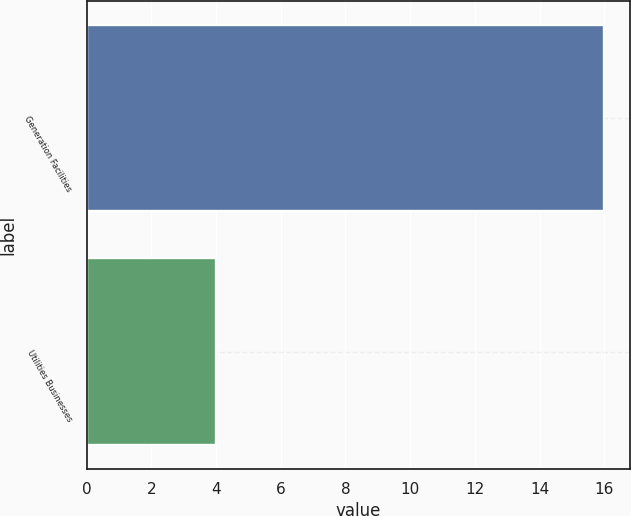<chart> <loc_0><loc_0><loc_500><loc_500><bar_chart><fcel>Generation Facilities<fcel>Utilities Businesses<nl><fcel>16<fcel>4<nl></chart> 